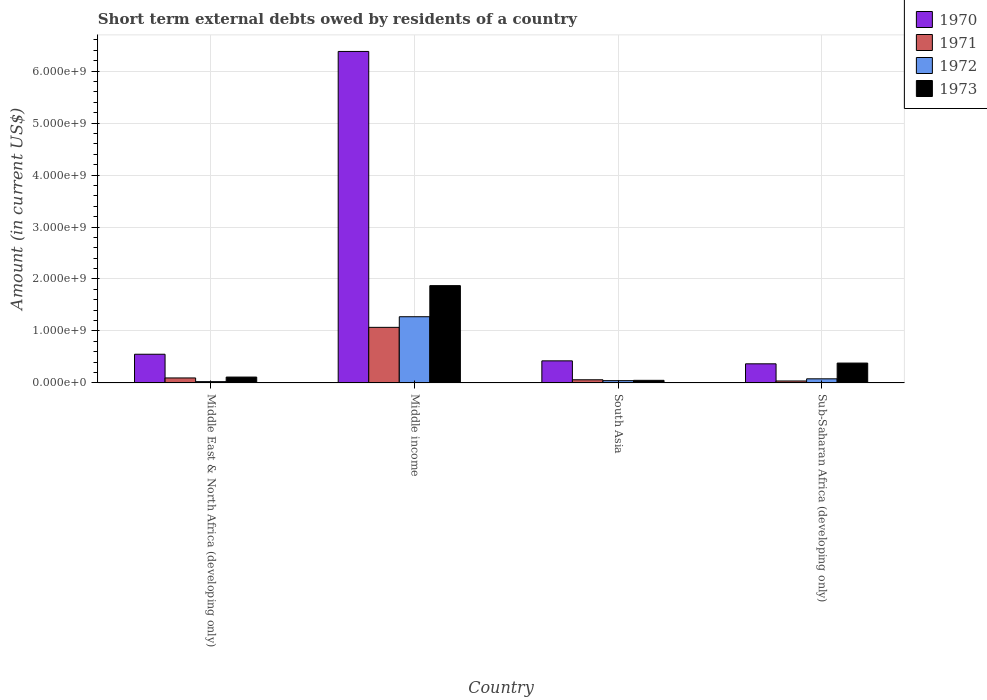How many different coloured bars are there?
Make the answer very short. 4. How many groups of bars are there?
Keep it short and to the point. 4. How many bars are there on the 4th tick from the left?
Provide a succinct answer. 4. How many bars are there on the 4th tick from the right?
Your response must be concise. 4. What is the label of the 4th group of bars from the left?
Offer a terse response. Sub-Saharan Africa (developing only). In how many cases, is the number of bars for a given country not equal to the number of legend labels?
Your answer should be very brief. 0. What is the amount of short-term external debts owed by residents in 1972 in Middle income?
Make the answer very short. 1.27e+09. Across all countries, what is the maximum amount of short-term external debts owed by residents in 1972?
Your answer should be very brief. 1.27e+09. Across all countries, what is the minimum amount of short-term external debts owed by residents in 1971?
Make the answer very short. 3.78e+07. In which country was the amount of short-term external debts owed by residents in 1970 maximum?
Provide a short and direct response. Middle income. In which country was the amount of short-term external debts owed by residents in 1971 minimum?
Your answer should be compact. Sub-Saharan Africa (developing only). What is the total amount of short-term external debts owed by residents in 1973 in the graph?
Provide a short and direct response. 2.42e+09. What is the difference between the amount of short-term external debts owed by residents in 1971 in Middle income and that in South Asia?
Your response must be concise. 1.01e+09. What is the difference between the amount of short-term external debts owed by residents in 1972 in Middle East & North Africa (developing only) and the amount of short-term external debts owed by residents in 1971 in Middle income?
Your answer should be very brief. -1.04e+09. What is the average amount of short-term external debts owed by residents in 1972 per country?
Your answer should be very brief. 3.56e+08. What is the ratio of the amount of short-term external debts owed by residents in 1970 in Middle East & North Africa (developing only) to that in Middle income?
Your answer should be very brief. 0.09. Is the amount of short-term external debts owed by residents in 1971 in Middle East & North Africa (developing only) less than that in South Asia?
Make the answer very short. No. What is the difference between the highest and the second highest amount of short-term external debts owed by residents in 1971?
Your answer should be compact. 9.73e+08. What is the difference between the highest and the lowest amount of short-term external debts owed by residents in 1973?
Offer a very short reply. 1.82e+09. Is the sum of the amount of short-term external debts owed by residents in 1972 in Middle income and Sub-Saharan Africa (developing only) greater than the maximum amount of short-term external debts owed by residents in 1971 across all countries?
Offer a very short reply. Yes. What does the 4th bar from the left in South Asia represents?
Give a very brief answer. 1973. Is it the case that in every country, the sum of the amount of short-term external debts owed by residents in 1972 and amount of short-term external debts owed by residents in 1973 is greater than the amount of short-term external debts owed by residents in 1971?
Your answer should be very brief. Yes. Are all the bars in the graph horizontal?
Your answer should be very brief. No. What is the difference between two consecutive major ticks on the Y-axis?
Provide a succinct answer. 1.00e+09. Are the values on the major ticks of Y-axis written in scientific E-notation?
Your answer should be compact. Yes. Does the graph contain grids?
Keep it short and to the point. Yes. How are the legend labels stacked?
Offer a very short reply. Vertical. What is the title of the graph?
Provide a short and direct response. Short term external debts owed by residents of a country. What is the label or title of the Y-axis?
Make the answer very short. Amount (in current US$). What is the Amount (in current US$) of 1970 in Middle East & North Africa (developing only)?
Your response must be concise. 5.52e+08. What is the Amount (in current US$) in 1971 in Middle East & North Africa (developing only)?
Your answer should be very brief. 9.60e+07. What is the Amount (in current US$) in 1972 in Middle East & North Africa (developing only)?
Your answer should be compact. 2.50e+07. What is the Amount (in current US$) of 1973 in Middle East & North Africa (developing only)?
Offer a very short reply. 1.13e+08. What is the Amount (in current US$) of 1970 in Middle income?
Provide a succinct answer. 6.38e+09. What is the Amount (in current US$) in 1971 in Middle income?
Give a very brief answer. 1.07e+09. What is the Amount (in current US$) of 1972 in Middle income?
Keep it short and to the point. 1.27e+09. What is the Amount (in current US$) in 1973 in Middle income?
Your response must be concise. 1.87e+09. What is the Amount (in current US$) in 1970 in South Asia?
Offer a very short reply. 4.25e+08. What is the Amount (in current US$) of 1971 in South Asia?
Offer a terse response. 6.10e+07. What is the Amount (in current US$) of 1972 in South Asia?
Offer a terse response. 4.40e+07. What is the Amount (in current US$) in 1973 in South Asia?
Provide a short and direct response. 5.00e+07. What is the Amount (in current US$) in 1970 in Sub-Saharan Africa (developing only)?
Your answer should be compact. 3.68e+08. What is the Amount (in current US$) of 1971 in Sub-Saharan Africa (developing only)?
Your response must be concise. 3.78e+07. What is the Amount (in current US$) in 1972 in Sub-Saharan Africa (developing only)?
Give a very brief answer. 7.93e+07. What is the Amount (in current US$) of 1973 in Sub-Saharan Africa (developing only)?
Your answer should be very brief. 3.82e+08. Across all countries, what is the maximum Amount (in current US$) of 1970?
Ensure brevity in your answer.  6.38e+09. Across all countries, what is the maximum Amount (in current US$) in 1971?
Ensure brevity in your answer.  1.07e+09. Across all countries, what is the maximum Amount (in current US$) of 1972?
Your response must be concise. 1.27e+09. Across all countries, what is the maximum Amount (in current US$) in 1973?
Your answer should be very brief. 1.87e+09. Across all countries, what is the minimum Amount (in current US$) of 1970?
Your answer should be very brief. 3.68e+08. Across all countries, what is the minimum Amount (in current US$) of 1971?
Offer a very short reply. 3.78e+07. Across all countries, what is the minimum Amount (in current US$) of 1972?
Provide a succinct answer. 2.50e+07. What is the total Amount (in current US$) in 1970 in the graph?
Offer a terse response. 7.72e+09. What is the total Amount (in current US$) in 1971 in the graph?
Make the answer very short. 1.26e+09. What is the total Amount (in current US$) in 1972 in the graph?
Make the answer very short. 1.42e+09. What is the total Amount (in current US$) in 1973 in the graph?
Offer a terse response. 2.42e+09. What is the difference between the Amount (in current US$) in 1970 in Middle East & North Africa (developing only) and that in Middle income?
Make the answer very short. -5.83e+09. What is the difference between the Amount (in current US$) in 1971 in Middle East & North Africa (developing only) and that in Middle income?
Your response must be concise. -9.73e+08. What is the difference between the Amount (in current US$) of 1972 in Middle East & North Africa (developing only) and that in Middle income?
Keep it short and to the point. -1.25e+09. What is the difference between the Amount (in current US$) in 1973 in Middle East & North Africa (developing only) and that in Middle income?
Keep it short and to the point. -1.76e+09. What is the difference between the Amount (in current US$) in 1970 in Middle East & North Africa (developing only) and that in South Asia?
Give a very brief answer. 1.27e+08. What is the difference between the Amount (in current US$) of 1971 in Middle East & North Africa (developing only) and that in South Asia?
Keep it short and to the point. 3.50e+07. What is the difference between the Amount (in current US$) in 1972 in Middle East & North Africa (developing only) and that in South Asia?
Your answer should be very brief. -1.90e+07. What is the difference between the Amount (in current US$) in 1973 in Middle East & North Africa (developing only) and that in South Asia?
Your answer should be very brief. 6.30e+07. What is the difference between the Amount (in current US$) in 1970 in Middle East & North Africa (developing only) and that in Sub-Saharan Africa (developing only)?
Provide a short and direct response. 1.84e+08. What is the difference between the Amount (in current US$) of 1971 in Middle East & North Africa (developing only) and that in Sub-Saharan Africa (developing only)?
Your response must be concise. 5.82e+07. What is the difference between the Amount (in current US$) of 1972 in Middle East & North Africa (developing only) and that in Sub-Saharan Africa (developing only)?
Your answer should be compact. -5.43e+07. What is the difference between the Amount (in current US$) of 1973 in Middle East & North Africa (developing only) and that in Sub-Saharan Africa (developing only)?
Ensure brevity in your answer.  -2.69e+08. What is the difference between the Amount (in current US$) of 1970 in Middle income and that in South Asia?
Provide a short and direct response. 5.95e+09. What is the difference between the Amount (in current US$) in 1971 in Middle income and that in South Asia?
Your answer should be very brief. 1.01e+09. What is the difference between the Amount (in current US$) of 1972 in Middle income and that in South Asia?
Your answer should be compact. 1.23e+09. What is the difference between the Amount (in current US$) in 1973 in Middle income and that in South Asia?
Ensure brevity in your answer.  1.82e+09. What is the difference between the Amount (in current US$) of 1970 in Middle income and that in Sub-Saharan Africa (developing only)?
Your response must be concise. 6.01e+09. What is the difference between the Amount (in current US$) in 1971 in Middle income and that in Sub-Saharan Africa (developing only)?
Ensure brevity in your answer.  1.03e+09. What is the difference between the Amount (in current US$) in 1972 in Middle income and that in Sub-Saharan Africa (developing only)?
Your answer should be compact. 1.19e+09. What is the difference between the Amount (in current US$) of 1973 in Middle income and that in Sub-Saharan Africa (developing only)?
Ensure brevity in your answer.  1.49e+09. What is the difference between the Amount (in current US$) of 1970 in South Asia and that in Sub-Saharan Africa (developing only)?
Offer a terse response. 5.71e+07. What is the difference between the Amount (in current US$) in 1971 in South Asia and that in Sub-Saharan Africa (developing only)?
Offer a terse response. 2.32e+07. What is the difference between the Amount (in current US$) of 1972 in South Asia and that in Sub-Saharan Africa (developing only)?
Ensure brevity in your answer.  -3.53e+07. What is the difference between the Amount (in current US$) in 1973 in South Asia and that in Sub-Saharan Africa (developing only)?
Offer a terse response. -3.32e+08. What is the difference between the Amount (in current US$) in 1970 in Middle East & North Africa (developing only) and the Amount (in current US$) in 1971 in Middle income?
Your answer should be compact. -5.17e+08. What is the difference between the Amount (in current US$) in 1970 in Middle East & North Africa (developing only) and the Amount (in current US$) in 1972 in Middle income?
Provide a short and direct response. -7.22e+08. What is the difference between the Amount (in current US$) of 1970 in Middle East & North Africa (developing only) and the Amount (in current US$) of 1973 in Middle income?
Your answer should be compact. -1.32e+09. What is the difference between the Amount (in current US$) of 1971 in Middle East & North Africa (developing only) and the Amount (in current US$) of 1972 in Middle income?
Make the answer very short. -1.18e+09. What is the difference between the Amount (in current US$) of 1971 in Middle East & North Africa (developing only) and the Amount (in current US$) of 1973 in Middle income?
Provide a succinct answer. -1.78e+09. What is the difference between the Amount (in current US$) of 1972 in Middle East & North Africa (developing only) and the Amount (in current US$) of 1973 in Middle income?
Give a very brief answer. -1.85e+09. What is the difference between the Amount (in current US$) in 1970 in Middle East & North Africa (developing only) and the Amount (in current US$) in 1971 in South Asia?
Your response must be concise. 4.91e+08. What is the difference between the Amount (in current US$) in 1970 in Middle East & North Africa (developing only) and the Amount (in current US$) in 1972 in South Asia?
Make the answer very short. 5.08e+08. What is the difference between the Amount (in current US$) in 1970 in Middle East & North Africa (developing only) and the Amount (in current US$) in 1973 in South Asia?
Offer a terse response. 5.02e+08. What is the difference between the Amount (in current US$) in 1971 in Middle East & North Africa (developing only) and the Amount (in current US$) in 1972 in South Asia?
Keep it short and to the point. 5.20e+07. What is the difference between the Amount (in current US$) in 1971 in Middle East & North Africa (developing only) and the Amount (in current US$) in 1973 in South Asia?
Make the answer very short. 4.60e+07. What is the difference between the Amount (in current US$) of 1972 in Middle East & North Africa (developing only) and the Amount (in current US$) of 1973 in South Asia?
Offer a terse response. -2.50e+07. What is the difference between the Amount (in current US$) in 1970 in Middle East & North Africa (developing only) and the Amount (in current US$) in 1971 in Sub-Saharan Africa (developing only)?
Provide a succinct answer. 5.14e+08. What is the difference between the Amount (in current US$) in 1970 in Middle East & North Africa (developing only) and the Amount (in current US$) in 1972 in Sub-Saharan Africa (developing only)?
Your response must be concise. 4.73e+08. What is the difference between the Amount (in current US$) of 1970 in Middle East & North Africa (developing only) and the Amount (in current US$) of 1973 in Sub-Saharan Africa (developing only)?
Keep it short and to the point. 1.70e+08. What is the difference between the Amount (in current US$) in 1971 in Middle East & North Africa (developing only) and the Amount (in current US$) in 1972 in Sub-Saharan Africa (developing only)?
Offer a terse response. 1.67e+07. What is the difference between the Amount (in current US$) in 1971 in Middle East & North Africa (developing only) and the Amount (in current US$) in 1973 in Sub-Saharan Africa (developing only)?
Your response must be concise. -2.86e+08. What is the difference between the Amount (in current US$) of 1972 in Middle East & North Africa (developing only) and the Amount (in current US$) of 1973 in Sub-Saharan Africa (developing only)?
Your answer should be very brief. -3.57e+08. What is the difference between the Amount (in current US$) in 1970 in Middle income and the Amount (in current US$) in 1971 in South Asia?
Keep it short and to the point. 6.32e+09. What is the difference between the Amount (in current US$) in 1970 in Middle income and the Amount (in current US$) in 1972 in South Asia?
Keep it short and to the point. 6.33e+09. What is the difference between the Amount (in current US$) in 1970 in Middle income and the Amount (in current US$) in 1973 in South Asia?
Make the answer very short. 6.33e+09. What is the difference between the Amount (in current US$) in 1971 in Middle income and the Amount (in current US$) in 1972 in South Asia?
Offer a terse response. 1.03e+09. What is the difference between the Amount (in current US$) of 1971 in Middle income and the Amount (in current US$) of 1973 in South Asia?
Provide a succinct answer. 1.02e+09. What is the difference between the Amount (in current US$) of 1972 in Middle income and the Amount (in current US$) of 1973 in South Asia?
Your response must be concise. 1.22e+09. What is the difference between the Amount (in current US$) in 1970 in Middle income and the Amount (in current US$) in 1971 in Sub-Saharan Africa (developing only)?
Give a very brief answer. 6.34e+09. What is the difference between the Amount (in current US$) in 1970 in Middle income and the Amount (in current US$) in 1972 in Sub-Saharan Africa (developing only)?
Ensure brevity in your answer.  6.30e+09. What is the difference between the Amount (in current US$) in 1970 in Middle income and the Amount (in current US$) in 1973 in Sub-Saharan Africa (developing only)?
Ensure brevity in your answer.  6.00e+09. What is the difference between the Amount (in current US$) of 1971 in Middle income and the Amount (in current US$) of 1972 in Sub-Saharan Africa (developing only)?
Your answer should be compact. 9.90e+08. What is the difference between the Amount (in current US$) in 1971 in Middle income and the Amount (in current US$) in 1973 in Sub-Saharan Africa (developing only)?
Provide a short and direct response. 6.87e+08. What is the difference between the Amount (in current US$) of 1972 in Middle income and the Amount (in current US$) of 1973 in Sub-Saharan Africa (developing only)?
Your response must be concise. 8.92e+08. What is the difference between the Amount (in current US$) in 1970 in South Asia and the Amount (in current US$) in 1971 in Sub-Saharan Africa (developing only)?
Your answer should be compact. 3.87e+08. What is the difference between the Amount (in current US$) in 1970 in South Asia and the Amount (in current US$) in 1972 in Sub-Saharan Africa (developing only)?
Your response must be concise. 3.46e+08. What is the difference between the Amount (in current US$) of 1970 in South Asia and the Amount (in current US$) of 1973 in Sub-Saharan Africa (developing only)?
Give a very brief answer. 4.27e+07. What is the difference between the Amount (in current US$) in 1971 in South Asia and the Amount (in current US$) in 1972 in Sub-Saharan Africa (developing only)?
Provide a short and direct response. -1.83e+07. What is the difference between the Amount (in current US$) of 1971 in South Asia and the Amount (in current US$) of 1973 in Sub-Saharan Africa (developing only)?
Ensure brevity in your answer.  -3.21e+08. What is the difference between the Amount (in current US$) in 1972 in South Asia and the Amount (in current US$) in 1973 in Sub-Saharan Africa (developing only)?
Provide a succinct answer. -3.38e+08. What is the average Amount (in current US$) of 1970 per country?
Give a very brief answer. 1.93e+09. What is the average Amount (in current US$) of 1971 per country?
Keep it short and to the point. 3.16e+08. What is the average Amount (in current US$) in 1972 per country?
Your answer should be compact. 3.56e+08. What is the average Amount (in current US$) in 1973 per country?
Ensure brevity in your answer.  6.04e+08. What is the difference between the Amount (in current US$) of 1970 and Amount (in current US$) of 1971 in Middle East & North Africa (developing only)?
Provide a short and direct response. 4.56e+08. What is the difference between the Amount (in current US$) of 1970 and Amount (in current US$) of 1972 in Middle East & North Africa (developing only)?
Keep it short and to the point. 5.27e+08. What is the difference between the Amount (in current US$) in 1970 and Amount (in current US$) in 1973 in Middle East & North Africa (developing only)?
Offer a terse response. 4.39e+08. What is the difference between the Amount (in current US$) of 1971 and Amount (in current US$) of 1972 in Middle East & North Africa (developing only)?
Your answer should be compact. 7.10e+07. What is the difference between the Amount (in current US$) in 1971 and Amount (in current US$) in 1973 in Middle East & North Africa (developing only)?
Keep it short and to the point. -1.70e+07. What is the difference between the Amount (in current US$) of 1972 and Amount (in current US$) of 1973 in Middle East & North Africa (developing only)?
Keep it short and to the point. -8.80e+07. What is the difference between the Amount (in current US$) of 1970 and Amount (in current US$) of 1971 in Middle income?
Ensure brevity in your answer.  5.31e+09. What is the difference between the Amount (in current US$) in 1970 and Amount (in current US$) in 1972 in Middle income?
Your answer should be compact. 5.10e+09. What is the difference between the Amount (in current US$) in 1970 and Amount (in current US$) in 1973 in Middle income?
Offer a very short reply. 4.51e+09. What is the difference between the Amount (in current US$) in 1971 and Amount (in current US$) in 1972 in Middle income?
Provide a short and direct response. -2.05e+08. What is the difference between the Amount (in current US$) in 1971 and Amount (in current US$) in 1973 in Middle income?
Keep it short and to the point. -8.03e+08. What is the difference between the Amount (in current US$) of 1972 and Amount (in current US$) of 1973 in Middle income?
Provide a succinct answer. -5.98e+08. What is the difference between the Amount (in current US$) of 1970 and Amount (in current US$) of 1971 in South Asia?
Your response must be concise. 3.64e+08. What is the difference between the Amount (in current US$) of 1970 and Amount (in current US$) of 1972 in South Asia?
Your answer should be compact. 3.81e+08. What is the difference between the Amount (in current US$) of 1970 and Amount (in current US$) of 1973 in South Asia?
Offer a terse response. 3.75e+08. What is the difference between the Amount (in current US$) in 1971 and Amount (in current US$) in 1972 in South Asia?
Provide a short and direct response. 1.70e+07. What is the difference between the Amount (in current US$) of 1971 and Amount (in current US$) of 1973 in South Asia?
Provide a succinct answer. 1.10e+07. What is the difference between the Amount (in current US$) in 1972 and Amount (in current US$) in 1973 in South Asia?
Your response must be concise. -6.00e+06. What is the difference between the Amount (in current US$) of 1970 and Amount (in current US$) of 1971 in Sub-Saharan Africa (developing only)?
Your answer should be compact. 3.30e+08. What is the difference between the Amount (in current US$) of 1970 and Amount (in current US$) of 1972 in Sub-Saharan Africa (developing only)?
Your answer should be very brief. 2.89e+08. What is the difference between the Amount (in current US$) in 1970 and Amount (in current US$) in 1973 in Sub-Saharan Africa (developing only)?
Ensure brevity in your answer.  -1.44e+07. What is the difference between the Amount (in current US$) in 1971 and Amount (in current US$) in 1972 in Sub-Saharan Africa (developing only)?
Provide a succinct answer. -4.15e+07. What is the difference between the Amount (in current US$) of 1971 and Amount (in current US$) of 1973 in Sub-Saharan Africa (developing only)?
Provide a succinct answer. -3.45e+08. What is the difference between the Amount (in current US$) in 1972 and Amount (in current US$) in 1973 in Sub-Saharan Africa (developing only)?
Your answer should be compact. -3.03e+08. What is the ratio of the Amount (in current US$) in 1970 in Middle East & North Africa (developing only) to that in Middle income?
Keep it short and to the point. 0.09. What is the ratio of the Amount (in current US$) of 1971 in Middle East & North Africa (developing only) to that in Middle income?
Give a very brief answer. 0.09. What is the ratio of the Amount (in current US$) in 1972 in Middle East & North Africa (developing only) to that in Middle income?
Your response must be concise. 0.02. What is the ratio of the Amount (in current US$) in 1973 in Middle East & North Africa (developing only) to that in Middle income?
Your answer should be compact. 0.06. What is the ratio of the Amount (in current US$) in 1970 in Middle East & North Africa (developing only) to that in South Asia?
Your response must be concise. 1.3. What is the ratio of the Amount (in current US$) in 1971 in Middle East & North Africa (developing only) to that in South Asia?
Your answer should be very brief. 1.57. What is the ratio of the Amount (in current US$) of 1972 in Middle East & North Africa (developing only) to that in South Asia?
Your response must be concise. 0.57. What is the ratio of the Amount (in current US$) in 1973 in Middle East & North Africa (developing only) to that in South Asia?
Ensure brevity in your answer.  2.26. What is the ratio of the Amount (in current US$) of 1970 in Middle East & North Africa (developing only) to that in Sub-Saharan Africa (developing only)?
Ensure brevity in your answer.  1.5. What is the ratio of the Amount (in current US$) in 1971 in Middle East & North Africa (developing only) to that in Sub-Saharan Africa (developing only)?
Keep it short and to the point. 2.54. What is the ratio of the Amount (in current US$) in 1972 in Middle East & North Africa (developing only) to that in Sub-Saharan Africa (developing only)?
Your response must be concise. 0.32. What is the ratio of the Amount (in current US$) of 1973 in Middle East & North Africa (developing only) to that in Sub-Saharan Africa (developing only)?
Keep it short and to the point. 0.3. What is the ratio of the Amount (in current US$) of 1970 in Middle income to that in South Asia?
Your response must be concise. 15.01. What is the ratio of the Amount (in current US$) of 1971 in Middle income to that in South Asia?
Provide a short and direct response. 17.53. What is the ratio of the Amount (in current US$) of 1972 in Middle income to that in South Asia?
Provide a short and direct response. 28.95. What is the ratio of the Amount (in current US$) in 1973 in Middle income to that in South Asia?
Your answer should be compact. 37.44. What is the ratio of the Amount (in current US$) in 1970 in Middle income to that in Sub-Saharan Africa (developing only)?
Your response must be concise. 17.34. What is the ratio of the Amount (in current US$) of 1971 in Middle income to that in Sub-Saharan Africa (developing only)?
Keep it short and to the point. 28.29. What is the ratio of the Amount (in current US$) in 1972 in Middle income to that in Sub-Saharan Africa (developing only)?
Provide a succinct answer. 16.06. What is the ratio of the Amount (in current US$) of 1973 in Middle income to that in Sub-Saharan Africa (developing only)?
Ensure brevity in your answer.  4.9. What is the ratio of the Amount (in current US$) in 1970 in South Asia to that in Sub-Saharan Africa (developing only)?
Provide a short and direct response. 1.16. What is the ratio of the Amount (in current US$) of 1971 in South Asia to that in Sub-Saharan Africa (developing only)?
Keep it short and to the point. 1.61. What is the ratio of the Amount (in current US$) in 1972 in South Asia to that in Sub-Saharan Africa (developing only)?
Your answer should be very brief. 0.55. What is the ratio of the Amount (in current US$) in 1973 in South Asia to that in Sub-Saharan Africa (developing only)?
Offer a very short reply. 0.13. What is the difference between the highest and the second highest Amount (in current US$) of 1970?
Offer a terse response. 5.83e+09. What is the difference between the highest and the second highest Amount (in current US$) of 1971?
Give a very brief answer. 9.73e+08. What is the difference between the highest and the second highest Amount (in current US$) of 1972?
Give a very brief answer. 1.19e+09. What is the difference between the highest and the second highest Amount (in current US$) of 1973?
Keep it short and to the point. 1.49e+09. What is the difference between the highest and the lowest Amount (in current US$) of 1970?
Ensure brevity in your answer.  6.01e+09. What is the difference between the highest and the lowest Amount (in current US$) in 1971?
Keep it short and to the point. 1.03e+09. What is the difference between the highest and the lowest Amount (in current US$) of 1972?
Make the answer very short. 1.25e+09. What is the difference between the highest and the lowest Amount (in current US$) of 1973?
Ensure brevity in your answer.  1.82e+09. 